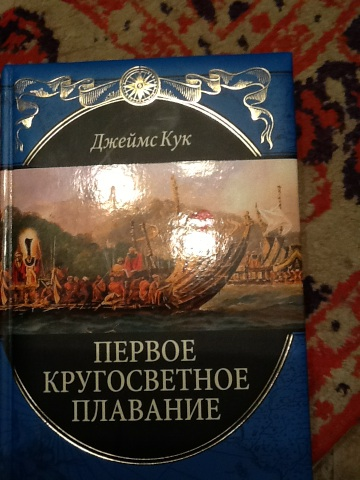Who is the author of this book and what were their contributions to exploration? The author of this book is James Cook, a renowned British explorer and navigator. He is best known for his three voyages to the Pacific Ocean, where he made detailed maps and numerous scientific observations that were crucial for the era of exploration. Can you give me more details about his expeditions? James Cook's three major voyages took place between 1768 and 1779. His first voyage was aboard the HMS Endeavour (1768-1771), during which he mapped the coastline of New Zealand and the eastern coast of Australia. His second voyage (1772-1775) involved circumnavigating the globe at a high southern latitude, disproving the existence of Terra Australis Incognita (a fabled southern continent). On his third voyage (1776-1779), Cook attempted to find the Northwest Passage and explored the coasts of North America and Siberia. These voyages greatly enhanced European knowledge of the Pacific region and were significant for the fields of cartography, astronomy, and natural history. 